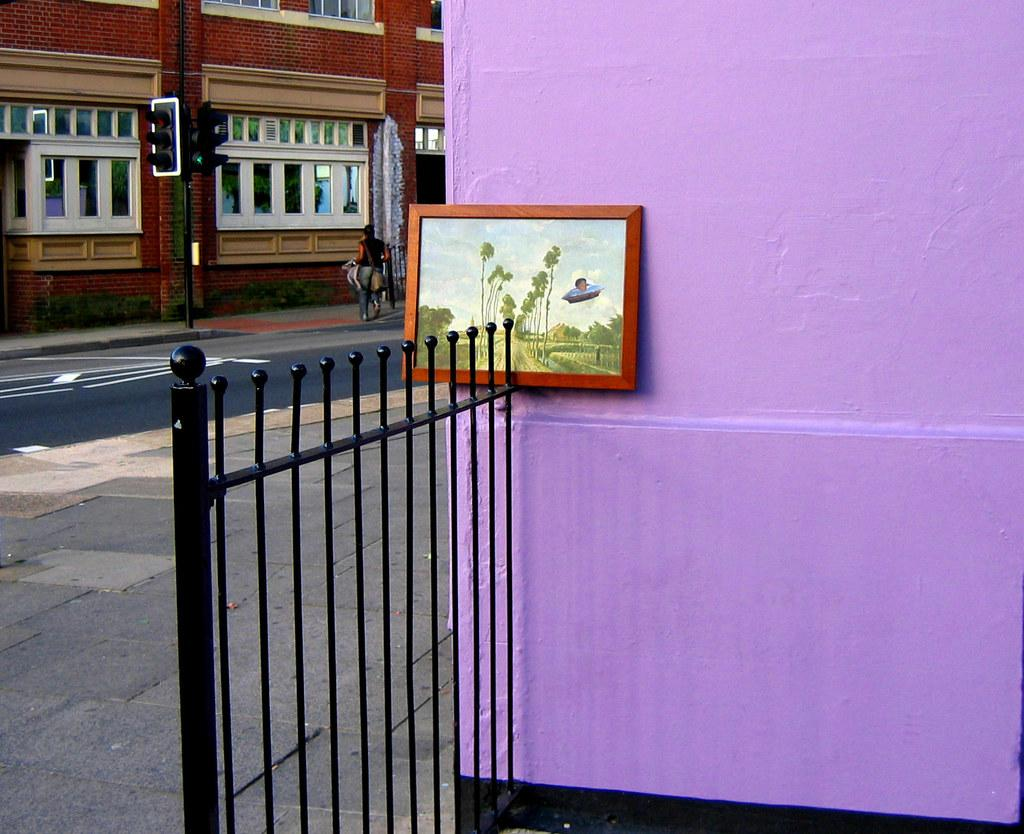What type of barrier is visible in the image? There is a black fence in the image. What can be seen attached to a wall in the image? There is a photo frame attached to a wall in the image. What is visible in the background of the image? There is a building and a person standing in the background of the image. What type of polish is being applied to the fence in the image? There is no indication in the image that any polish is being applied to the fence. Can you tell me how deep the river is in the image? There is no river present in the image. 